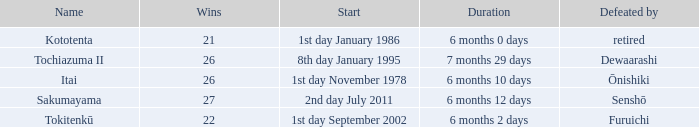Which duration was defeated by retired? 6 months 0 days. 